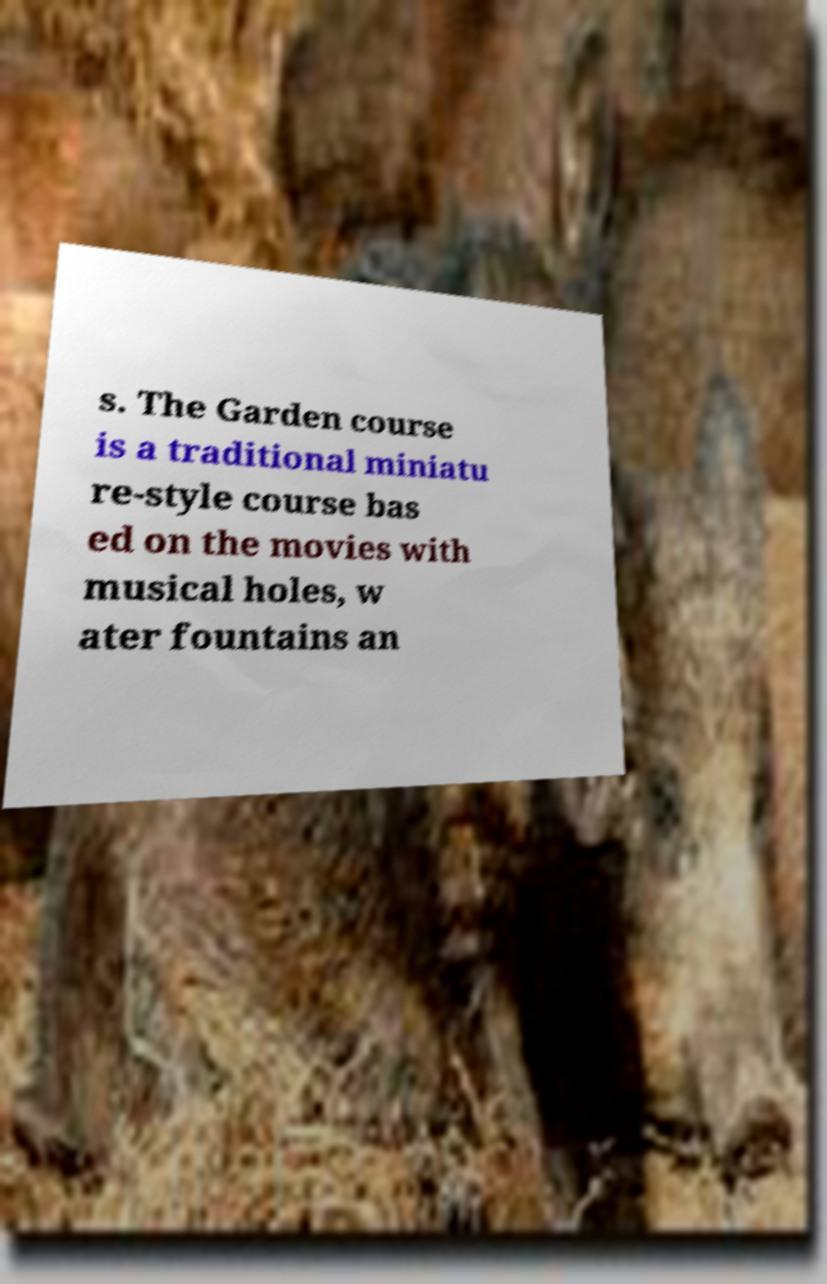Please identify and transcribe the text found in this image. s. The Garden course is a traditional miniatu re-style course bas ed on the movies with musical holes, w ater fountains an 